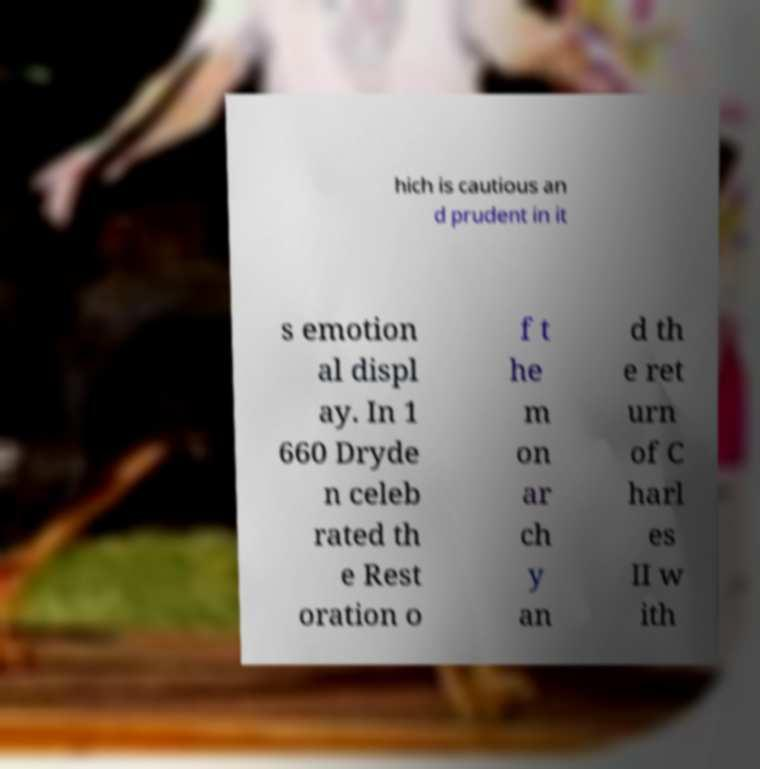Could you assist in decoding the text presented in this image and type it out clearly? hich is cautious an d prudent in it s emotion al displ ay. In 1 660 Dryde n celeb rated th e Rest oration o f t he m on ar ch y an d th e ret urn of C harl es II w ith 